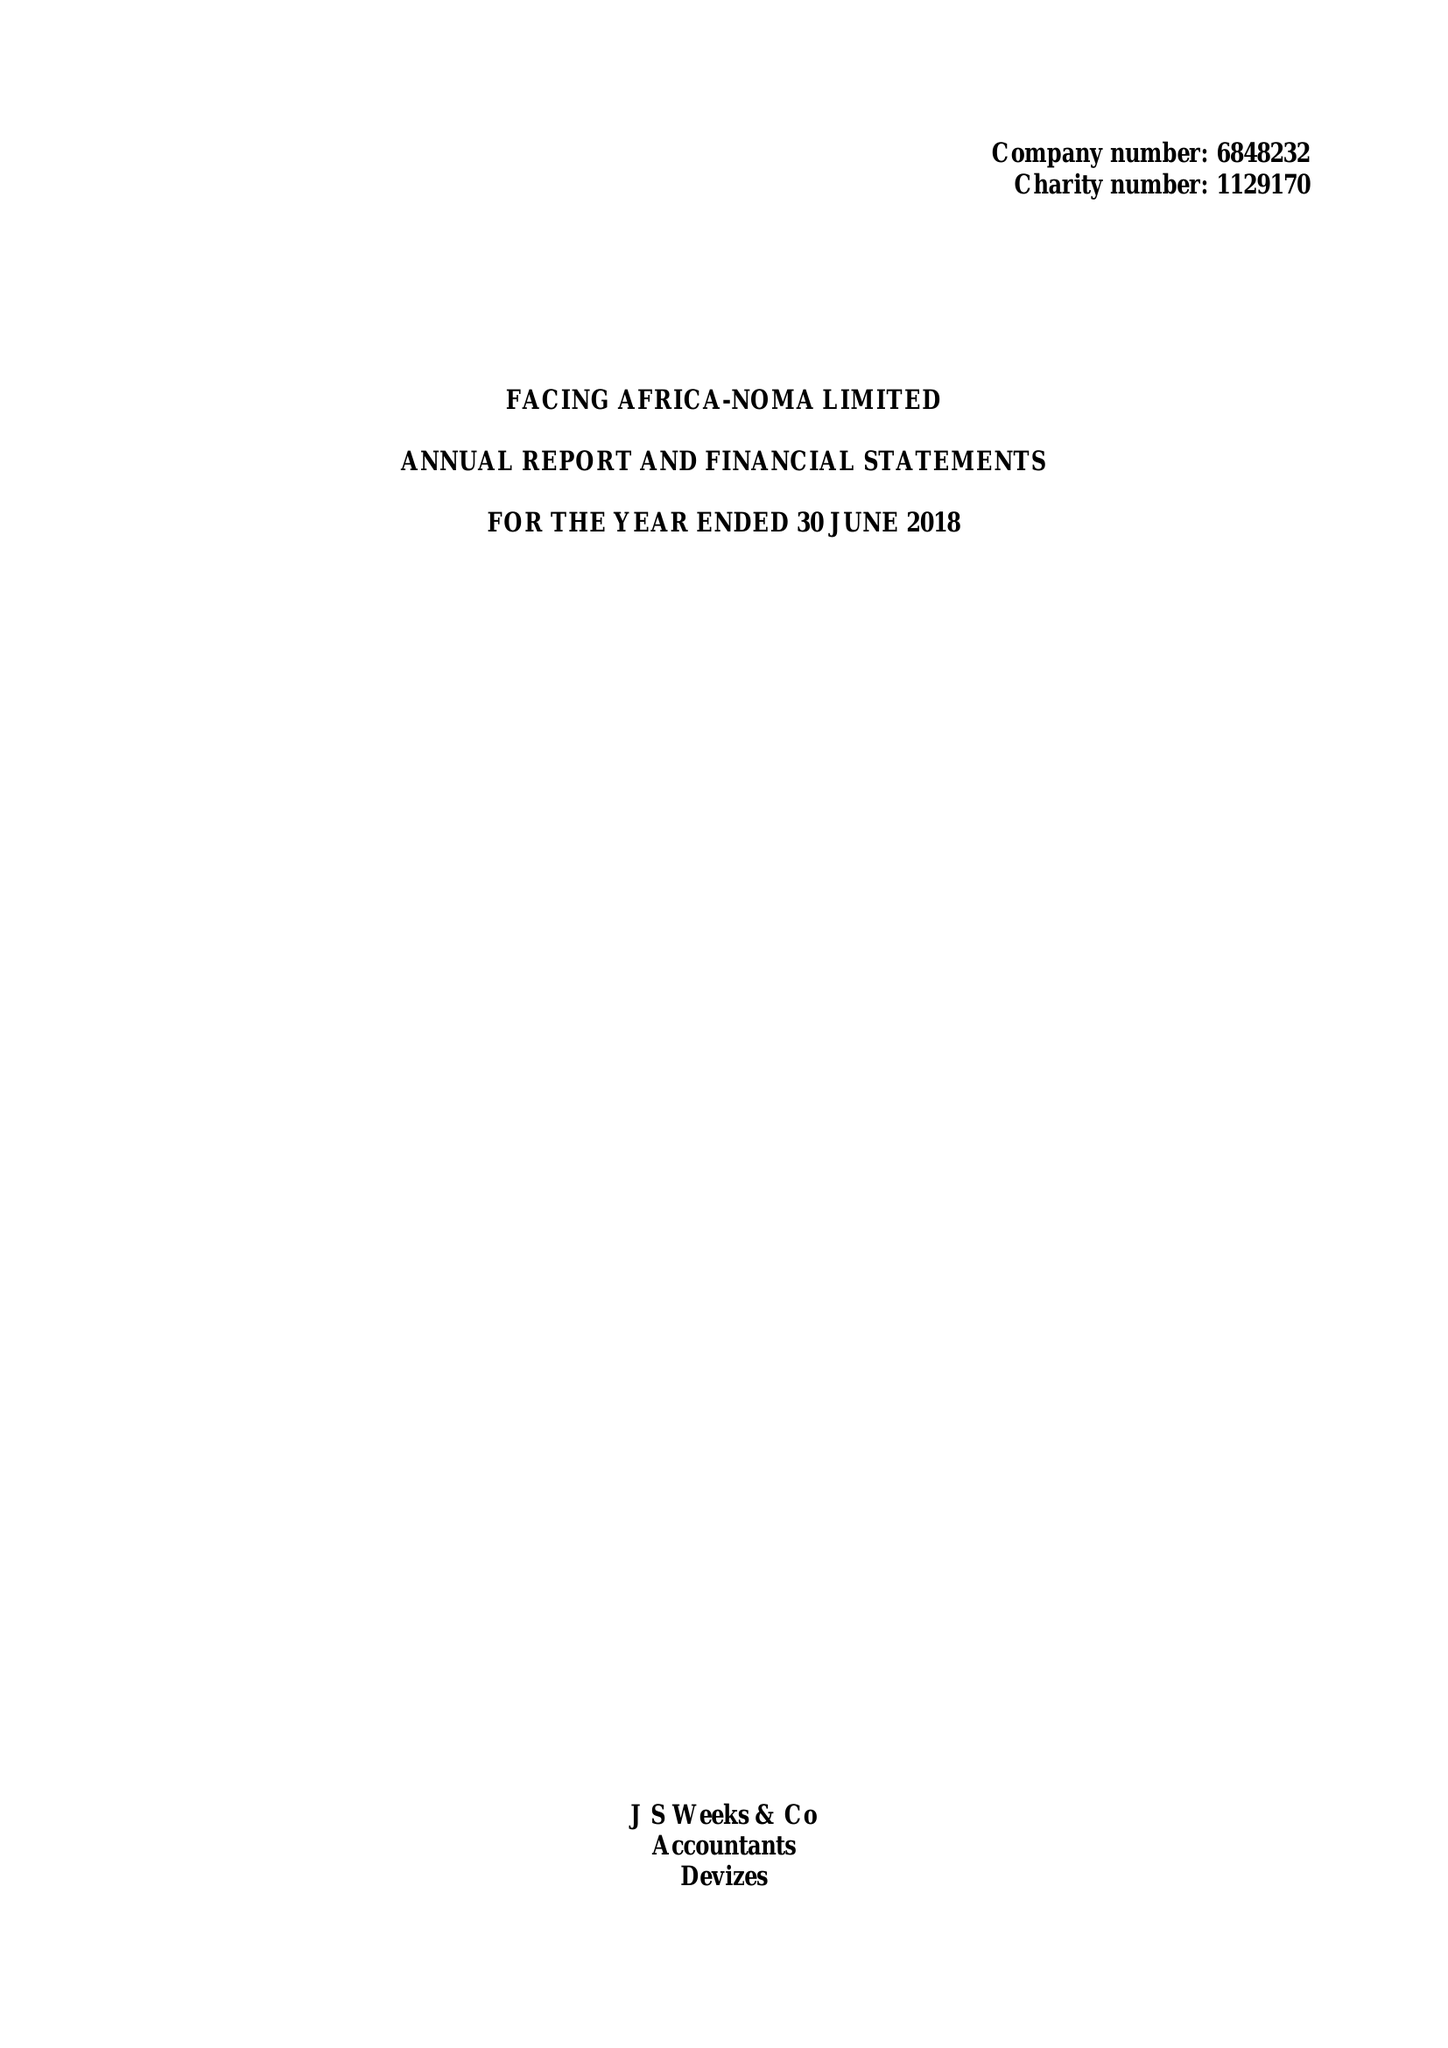What is the value for the address__postcode?
Answer the question using a single word or phrase. SN10 1DF 